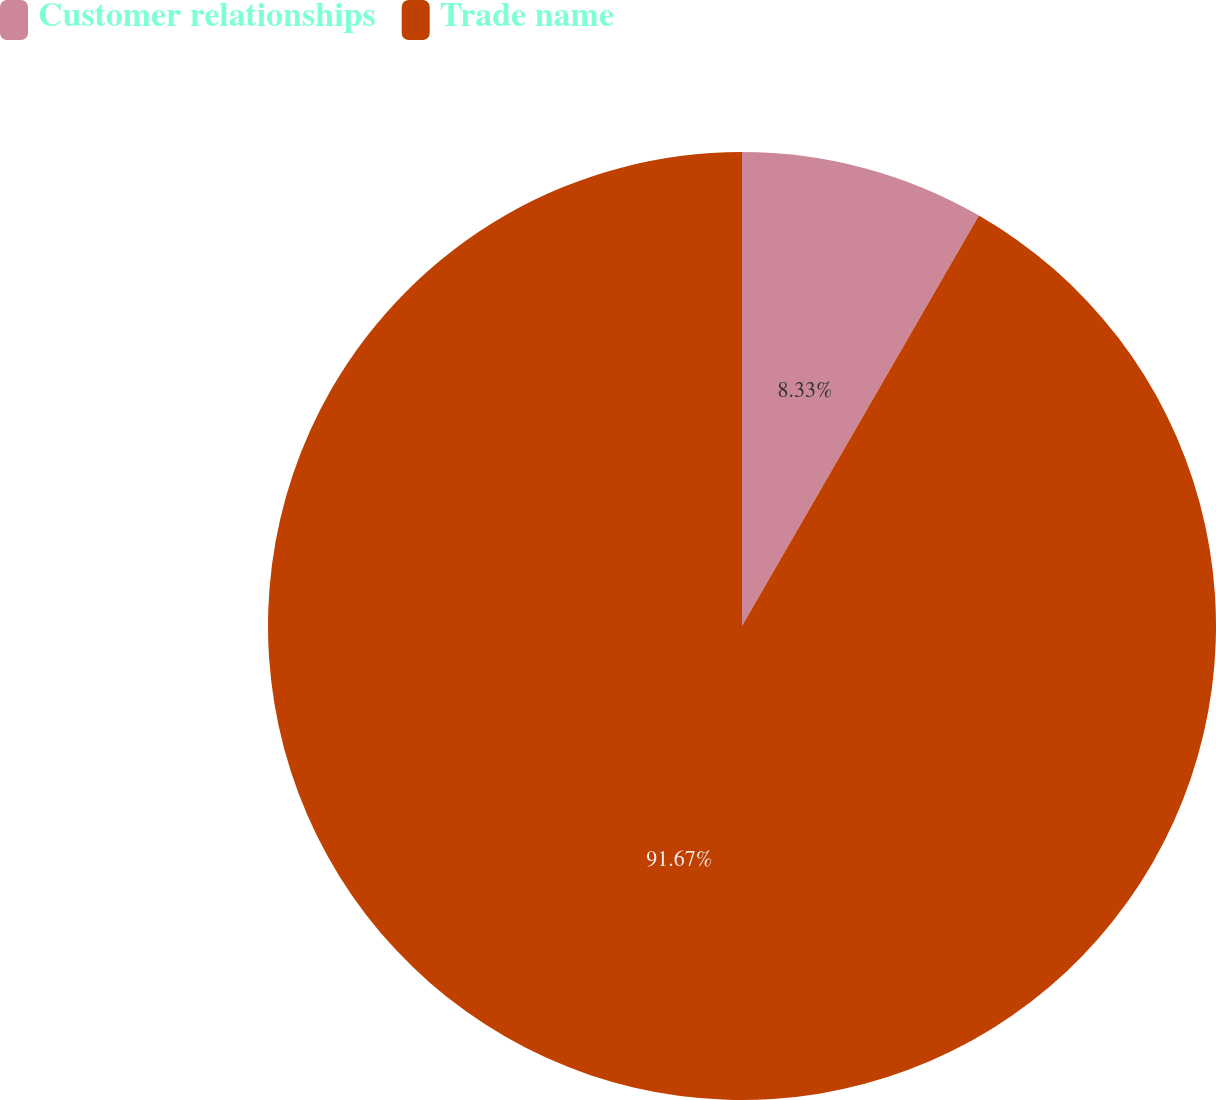<chart> <loc_0><loc_0><loc_500><loc_500><pie_chart><fcel>Customer relationships<fcel>Trade name<nl><fcel>8.33%<fcel>91.67%<nl></chart> 